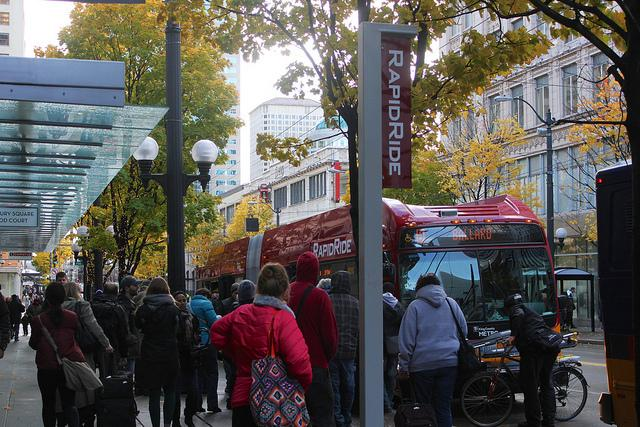Who are the people gathering there?

Choices:
A) friends
B) coworkers
C) tourists
D) students tourists 